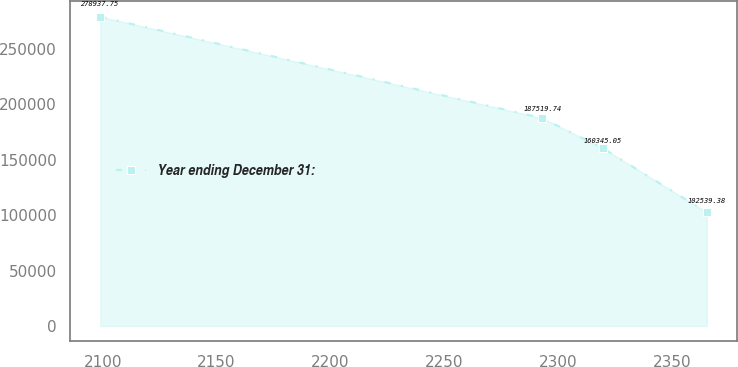<chart> <loc_0><loc_0><loc_500><loc_500><line_chart><ecel><fcel>Year ending December 31:<nl><fcel>2098.99<fcel>278938<nl><fcel>2292.97<fcel>187520<nl><fcel>2319.59<fcel>160345<nl><fcel>2365.23<fcel>102539<nl></chart> 